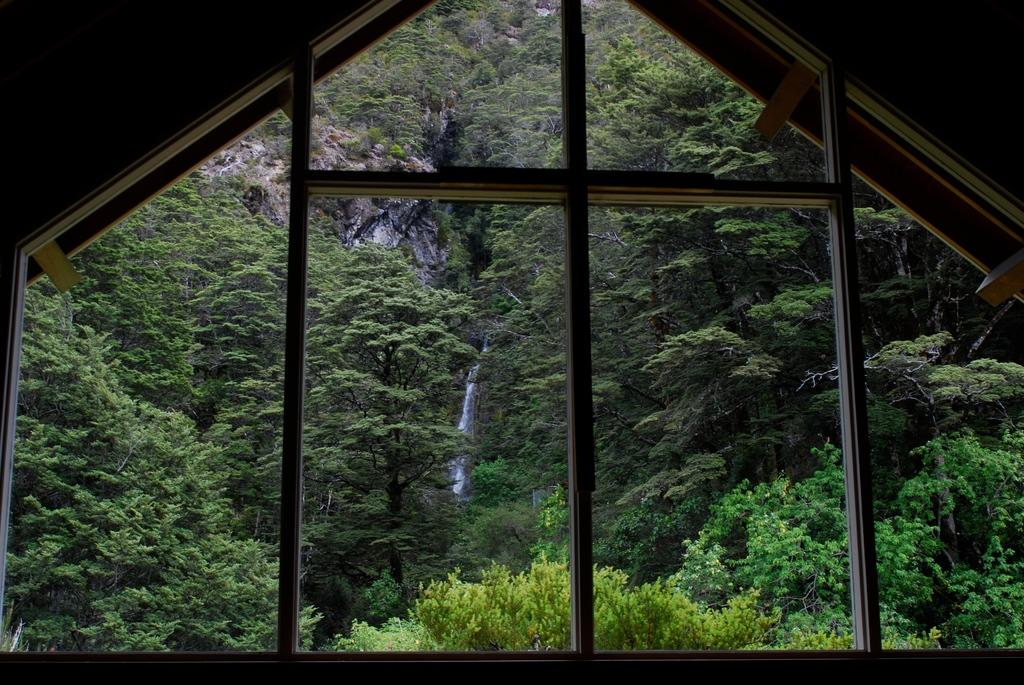What structure is present in the image? There is a shed in the image. What can be seen in the background of the image? There are trees in the background of the image. What type of payment is being made in the image? There is no payment being made in the image; it only features a shed and trees in the background. What is the cause of the trees in the image? The cause of the trees in the image cannot be determined from the image itself, as it only shows their presence and not their origin. 